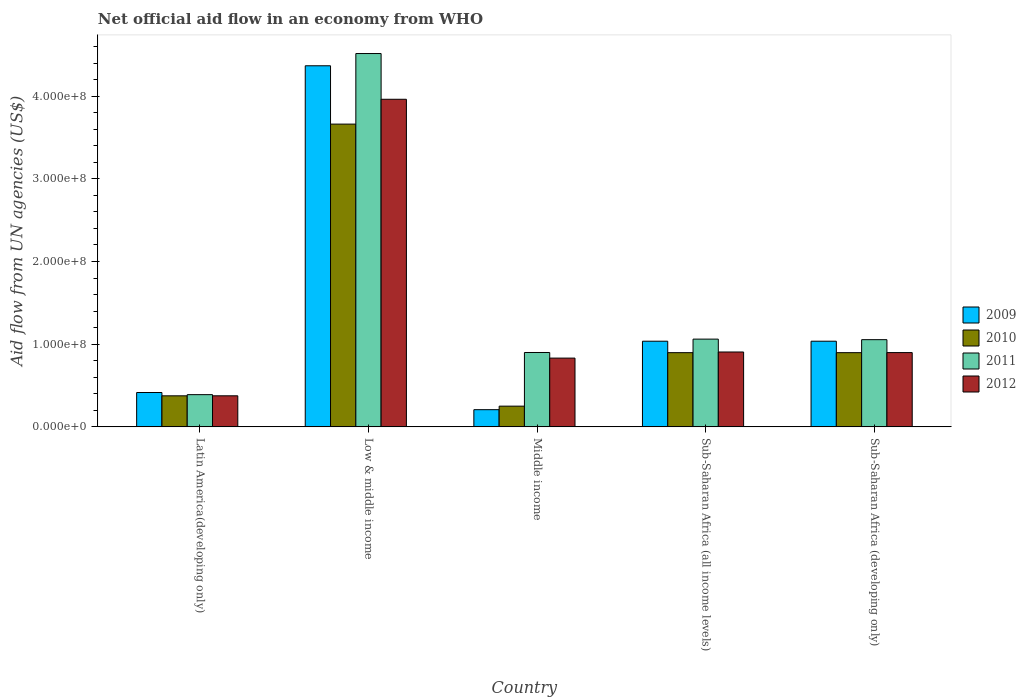How many different coloured bars are there?
Make the answer very short. 4. How many groups of bars are there?
Ensure brevity in your answer.  5. Are the number of bars per tick equal to the number of legend labels?
Your answer should be very brief. Yes. Are the number of bars on each tick of the X-axis equal?
Make the answer very short. Yes. What is the label of the 1st group of bars from the left?
Ensure brevity in your answer.  Latin America(developing only). What is the net official aid flow in 2011 in Latin America(developing only)?
Ensure brevity in your answer.  3.90e+07. Across all countries, what is the maximum net official aid flow in 2010?
Your response must be concise. 3.66e+08. Across all countries, what is the minimum net official aid flow in 2012?
Keep it short and to the point. 3.76e+07. In which country was the net official aid flow in 2011 minimum?
Offer a very short reply. Latin America(developing only). What is the total net official aid flow in 2010 in the graph?
Provide a succinct answer. 6.08e+08. What is the difference between the net official aid flow in 2012 in Middle income and that in Sub-Saharan Africa (all income levels)?
Offer a terse response. -7.39e+06. What is the difference between the net official aid flow in 2010 in Middle income and the net official aid flow in 2011 in Sub-Saharan Africa (all income levels)?
Offer a terse response. -8.11e+07. What is the average net official aid flow in 2009 per country?
Keep it short and to the point. 1.41e+08. What is the difference between the net official aid flow of/in 2011 and net official aid flow of/in 2010 in Low & middle income?
Offer a very short reply. 8.54e+07. In how many countries, is the net official aid flow in 2009 greater than 420000000 US$?
Provide a short and direct response. 1. What is the ratio of the net official aid flow in 2011 in Low & middle income to that in Middle income?
Make the answer very short. 5.02. Is the net official aid flow in 2011 in Latin America(developing only) less than that in Low & middle income?
Give a very brief answer. Yes. Is the difference between the net official aid flow in 2011 in Low & middle income and Sub-Saharan Africa (developing only) greater than the difference between the net official aid flow in 2010 in Low & middle income and Sub-Saharan Africa (developing only)?
Your response must be concise. Yes. What is the difference between the highest and the second highest net official aid flow in 2010?
Your answer should be very brief. 2.76e+08. What is the difference between the highest and the lowest net official aid flow in 2010?
Your answer should be compact. 3.41e+08. In how many countries, is the net official aid flow in 2010 greater than the average net official aid flow in 2010 taken over all countries?
Your response must be concise. 1. Is the sum of the net official aid flow in 2009 in Latin America(developing only) and Sub-Saharan Africa (all income levels) greater than the maximum net official aid flow in 2012 across all countries?
Your response must be concise. No. What does the 4th bar from the right in Sub-Saharan Africa (developing only) represents?
Ensure brevity in your answer.  2009. Is it the case that in every country, the sum of the net official aid flow in 2009 and net official aid flow in 2010 is greater than the net official aid flow in 2011?
Your answer should be very brief. No. Does the graph contain any zero values?
Offer a very short reply. No. How many legend labels are there?
Your answer should be compact. 4. What is the title of the graph?
Provide a succinct answer. Net official aid flow in an economy from WHO. What is the label or title of the X-axis?
Ensure brevity in your answer.  Country. What is the label or title of the Y-axis?
Give a very brief answer. Aid flow from UN agencies (US$). What is the Aid flow from UN agencies (US$) of 2009 in Latin America(developing only)?
Your response must be concise. 4.16e+07. What is the Aid flow from UN agencies (US$) of 2010 in Latin America(developing only)?
Offer a very short reply. 3.76e+07. What is the Aid flow from UN agencies (US$) of 2011 in Latin America(developing only)?
Offer a very short reply. 3.90e+07. What is the Aid flow from UN agencies (US$) in 2012 in Latin America(developing only)?
Your answer should be very brief. 3.76e+07. What is the Aid flow from UN agencies (US$) in 2009 in Low & middle income?
Offer a terse response. 4.37e+08. What is the Aid flow from UN agencies (US$) of 2010 in Low & middle income?
Give a very brief answer. 3.66e+08. What is the Aid flow from UN agencies (US$) in 2011 in Low & middle income?
Your answer should be compact. 4.52e+08. What is the Aid flow from UN agencies (US$) in 2012 in Low & middle income?
Give a very brief answer. 3.96e+08. What is the Aid flow from UN agencies (US$) in 2009 in Middle income?
Offer a terse response. 2.08e+07. What is the Aid flow from UN agencies (US$) in 2010 in Middle income?
Provide a succinct answer. 2.51e+07. What is the Aid flow from UN agencies (US$) in 2011 in Middle income?
Give a very brief answer. 9.00e+07. What is the Aid flow from UN agencies (US$) in 2012 in Middle income?
Provide a short and direct response. 8.32e+07. What is the Aid flow from UN agencies (US$) in 2009 in Sub-Saharan Africa (all income levels)?
Provide a succinct answer. 1.04e+08. What is the Aid flow from UN agencies (US$) of 2010 in Sub-Saharan Africa (all income levels)?
Provide a short and direct response. 8.98e+07. What is the Aid flow from UN agencies (US$) in 2011 in Sub-Saharan Africa (all income levels)?
Make the answer very short. 1.06e+08. What is the Aid flow from UN agencies (US$) of 2012 in Sub-Saharan Africa (all income levels)?
Offer a terse response. 9.06e+07. What is the Aid flow from UN agencies (US$) in 2009 in Sub-Saharan Africa (developing only)?
Make the answer very short. 1.04e+08. What is the Aid flow from UN agencies (US$) in 2010 in Sub-Saharan Africa (developing only)?
Make the answer very short. 8.98e+07. What is the Aid flow from UN agencies (US$) in 2011 in Sub-Saharan Africa (developing only)?
Make the answer very short. 1.05e+08. What is the Aid flow from UN agencies (US$) in 2012 in Sub-Saharan Africa (developing only)?
Provide a succinct answer. 8.98e+07. Across all countries, what is the maximum Aid flow from UN agencies (US$) in 2009?
Your response must be concise. 4.37e+08. Across all countries, what is the maximum Aid flow from UN agencies (US$) in 2010?
Your answer should be compact. 3.66e+08. Across all countries, what is the maximum Aid flow from UN agencies (US$) in 2011?
Your response must be concise. 4.52e+08. Across all countries, what is the maximum Aid flow from UN agencies (US$) of 2012?
Make the answer very short. 3.96e+08. Across all countries, what is the minimum Aid flow from UN agencies (US$) of 2009?
Offer a terse response. 2.08e+07. Across all countries, what is the minimum Aid flow from UN agencies (US$) of 2010?
Give a very brief answer. 2.51e+07. Across all countries, what is the minimum Aid flow from UN agencies (US$) of 2011?
Your response must be concise. 3.90e+07. Across all countries, what is the minimum Aid flow from UN agencies (US$) in 2012?
Make the answer very short. 3.76e+07. What is the total Aid flow from UN agencies (US$) in 2009 in the graph?
Provide a succinct answer. 7.06e+08. What is the total Aid flow from UN agencies (US$) in 2010 in the graph?
Provide a succinct answer. 6.08e+08. What is the total Aid flow from UN agencies (US$) in 2011 in the graph?
Offer a very short reply. 7.92e+08. What is the total Aid flow from UN agencies (US$) of 2012 in the graph?
Make the answer very short. 6.97e+08. What is the difference between the Aid flow from UN agencies (US$) in 2009 in Latin America(developing only) and that in Low & middle income?
Your response must be concise. -3.95e+08. What is the difference between the Aid flow from UN agencies (US$) of 2010 in Latin America(developing only) and that in Low & middle income?
Ensure brevity in your answer.  -3.29e+08. What is the difference between the Aid flow from UN agencies (US$) in 2011 in Latin America(developing only) and that in Low & middle income?
Give a very brief answer. -4.13e+08. What is the difference between the Aid flow from UN agencies (US$) of 2012 in Latin America(developing only) and that in Low & middle income?
Offer a very short reply. -3.59e+08. What is the difference between the Aid flow from UN agencies (US$) of 2009 in Latin America(developing only) and that in Middle income?
Offer a very short reply. 2.08e+07. What is the difference between the Aid flow from UN agencies (US$) in 2010 in Latin America(developing only) and that in Middle income?
Your answer should be very brief. 1.25e+07. What is the difference between the Aid flow from UN agencies (US$) of 2011 in Latin America(developing only) and that in Middle income?
Your answer should be compact. -5.10e+07. What is the difference between the Aid flow from UN agencies (US$) of 2012 in Latin America(developing only) and that in Middle income?
Offer a terse response. -4.56e+07. What is the difference between the Aid flow from UN agencies (US$) of 2009 in Latin America(developing only) and that in Sub-Saharan Africa (all income levels)?
Keep it short and to the point. -6.20e+07. What is the difference between the Aid flow from UN agencies (US$) of 2010 in Latin America(developing only) and that in Sub-Saharan Africa (all income levels)?
Ensure brevity in your answer.  -5.22e+07. What is the difference between the Aid flow from UN agencies (US$) in 2011 in Latin America(developing only) and that in Sub-Saharan Africa (all income levels)?
Make the answer very short. -6.72e+07. What is the difference between the Aid flow from UN agencies (US$) of 2012 in Latin America(developing only) and that in Sub-Saharan Africa (all income levels)?
Provide a short and direct response. -5.30e+07. What is the difference between the Aid flow from UN agencies (US$) in 2009 in Latin America(developing only) and that in Sub-Saharan Africa (developing only)?
Keep it short and to the point. -6.20e+07. What is the difference between the Aid flow from UN agencies (US$) in 2010 in Latin America(developing only) and that in Sub-Saharan Africa (developing only)?
Keep it short and to the point. -5.22e+07. What is the difference between the Aid flow from UN agencies (US$) in 2011 in Latin America(developing only) and that in Sub-Saharan Africa (developing only)?
Your response must be concise. -6.65e+07. What is the difference between the Aid flow from UN agencies (US$) in 2012 in Latin America(developing only) and that in Sub-Saharan Africa (developing only)?
Offer a terse response. -5.23e+07. What is the difference between the Aid flow from UN agencies (US$) in 2009 in Low & middle income and that in Middle income?
Offer a terse response. 4.16e+08. What is the difference between the Aid flow from UN agencies (US$) in 2010 in Low & middle income and that in Middle income?
Ensure brevity in your answer.  3.41e+08. What is the difference between the Aid flow from UN agencies (US$) of 2011 in Low & middle income and that in Middle income?
Make the answer very short. 3.62e+08. What is the difference between the Aid flow from UN agencies (US$) of 2012 in Low & middle income and that in Middle income?
Ensure brevity in your answer.  3.13e+08. What is the difference between the Aid flow from UN agencies (US$) of 2009 in Low & middle income and that in Sub-Saharan Africa (all income levels)?
Offer a very short reply. 3.33e+08. What is the difference between the Aid flow from UN agencies (US$) in 2010 in Low & middle income and that in Sub-Saharan Africa (all income levels)?
Ensure brevity in your answer.  2.76e+08. What is the difference between the Aid flow from UN agencies (US$) of 2011 in Low & middle income and that in Sub-Saharan Africa (all income levels)?
Your answer should be very brief. 3.45e+08. What is the difference between the Aid flow from UN agencies (US$) of 2012 in Low & middle income and that in Sub-Saharan Africa (all income levels)?
Your response must be concise. 3.06e+08. What is the difference between the Aid flow from UN agencies (US$) in 2009 in Low & middle income and that in Sub-Saharan Africa (developing only)?
Offer a terse response. 3.33e+08. What is the difference between the Aid flow from UN agencies (US$) in 2010 in Low & middle income and that in Sub-Saharan Africa (developing only)?
Provide a short and direct response. 2.76e+08. What is the difference between the Aid flow from UN agencies (US$) in 2011 in Low & middle income and that in Sub-Saharan Africa (developing only)?
Offer a terse response. 3.46e+08. What is the difference between the Aid flow from UN agencies (US$) in 2012 in Low & middle income and that in Sub-Saharan Africa (developing only)?
Ensure brevity in your answer.  3.06e+08. What is the difference between the Aid flow from UN agencies (US$) of 2009 in Middle income and that in Sub-Saharan Africa (all income levels)?
Keep it short and to the point. -8.28e+07. What is the difference between the Aid flow from UN agencies (US$) in 2010 in Middle income and that in Sub-Saharan Africa (all income levels)?
Offer a terse response. -6.47e+07. What is the difference between the Aid flow from UN agencies (US$) in 2011 in Middle income and that in Sub-Saharan Africa (all income levels)?
Your response must be concise. -1.62e+07. What is the difference between the Aid flow from UN agencies (US$) in 2012 in Middle income and that in Sub-Saharan Africa (all income levels)?
Offer a very short reply. -7.39e+06. What is the difference between the Aid flow from UN agencies (US$) of 2009 in Middle income and that in Sub-Saharan Africa (developing only)?
Ensure brevity in your answer.  -8.28e+07. What is the difference between the Aid flow from UN agencies (US$) in 2010 in Middle income and that in Sub-Saharan Africa (developing only)?
Keep it short and to the point. -6.47e+07. What is the difference between the Aid flow from UN agencies (US$) of 2011 in Middle income and that in Sub-Saharan Africa (developing only)?
Your response must be concise. -1.55e+07. What is the difference between the Aid flow from UN agencies (US$) in 2012 in Middle income and that in Sub-Saharan Africa (developing only)?
Provide a short and direct response. -6.67e+06. What is the difference between the Aid flow from UN agencies (US$) of 2009 in Sub-Saharan Africa (all income levels) and that in Sub-Saharan Africa (developing only)?
Make the answer very short. 0. What is the difference between the Aid flow from UN agencies (US$) in 2011 in Sub-Saharan Africa (all income levels) and that in Sub-Saharan Africa (developing only)?
Your answer should be compact. 6.70e+05. What is the difference between the Aid flow from UN agencies (US$) in 2012 in Sub-Saharan Africa (all income levels) and that in Sub-Saharan Africa (developing only)?
Provide a short and direct response. 7.20e+05. What is the difference between the Aid flow from UN agencies (US$) in 2009 in Latin America(developing only) and the Aid flow from UN agencies (US$) in 2010 in Low & middle income?
Ensure brevity in your answer.  -3.25e+08. What is the difference between the Aid flow from UN agencies (US$) in 2009 in Latin America(developing only) and the Aid flow from UN agencies (US$) in 2011 in Low & middle income?
Give a very brief answer. -4.10e+08. What is the difference between the Aid flow from UN agencies (US$) in 2009 in Latin America(developing only) and the Aid flow from UN agencies (US$) in 2012 in Low & middle income?
Give a very brief answer. -3.55e+08. What is the difference between the Aid flow from UN agencies (US$) in 2010 in Latin America(developing only) and the Aid flow from UN agencies (US$) in 2011 in Low & middle income?
Your response must be concise. -4.14e+08. What is the difference between the Aid flow from UN agencies (US$) of 2010 in Latin America(developing only) and the Aid flow from UN agencies (US$) of 2012 in Low & middle income?
Your response must be concise. -3.59e+08. What is the difference between the Aid flow from UN agencies (US$) in 2011 in Latin America(developing only) and the Aid flow from UN agencies (US$) in 2012 in Low & middle income?
Keep it short and to the point. -3.57e+08. What is the difference between the Aid flow from UN agencies (US$) of 2009 in Latin America(developing only) and the Aid flow from UN agencies (US$) of 2010 in Middle income?
Give a very brief answer. 1.65e+07. What is the difference between the Aid flow from UN agencies (US$) in 2009 in Latin America(developing only) and the Aid flow from UN agencies (US$) in 2011 in Middle income?
Your answer should be very brief. -4.84e+07. What is the difference between the Aid flow from UN agencies (US$) of 2009 in Latin America(developing only) and the Aid flow from UN agencies (US$) of 2012 in Middle income?
Keep it short and to the point. -4.16e+07. What is the difference between the Aid flow from UN agencies (US$) of 2010 in Latin America(developing only) and the Aid flow from UN agencies (US$) of 2011 in Middle income?
Keep it short and to the point. -5.24e+07. What is the difference between the Aid flow from UN agencies (US$) in 2010 in Latin America(developing only) and the Aid flow from UN agencies (US$) in 2012 in Middle income?
Your answer should be compact. -4.56e+07. What is the difference between the Aid flow from UN agencies (US$) of 2011 in Latin America(developing only) and the Aid flow from UN agencies (US$) of 2012 in Middle income?
Offer a very short reply. -4.42e+07. What is the difference between the Aid flow from UN agencies (US$) in 2009 in Latin America(developing only) and the Aid flow from UN agencies (US$) in 2010 in Sub-Saharan Africa (all income levels)?
Provide a short and direct response. -4.82e+07. What is the difference between the Aid flow from UN agencies (US$) in 2009 in Latin America(developing only) and the Aid flow from UN agencies (US$) in 2011 in Sub-Saharan Africa (all income levels)?
Give a very brief answer. -6.46e+07. What is the difference between the Aid flow from UN agencies (US$) of 2009 in Latin America(developing only) and the Aid flow from UN agencies (US$) of 2012 in Sub-Saharan Africa (all income levels)?
Provide a short and direct response. -4.90e+07. What is the difference between the Aid flow from UN agencies (US$) in 2010 in Latin America(developing only) and the Aid flow from UN agencies (US$) in 2011 in Sub-Saharan Africa (all income levels)?
Ensure brevity in your answer.  -6.86e+07. What is the difference between the Aid flow from UN agencies (US$) in 2010 in Latin America(developing only) and the Aid flow from UN agencies (US$) in 2012 in Sub-Saharan Africa (all income levels)?
Provide a succinct answer. -5.30e+07. What is the difference between the Aid flow from UN agencies (US$) of 2011 in Latin America(developing only) and the Aid flow from UN agencies (US$) of 2012 in Sub-Saharan Africa (all income levels)?
Your answer should be compact. -5.16e+07. What is the difference between the Aid flow from UN agencies (US$) in 2009 in Latin America(developing only) and the Aid flow from UN agencies (US$) in 2010 in Sub-Saharan Africa (developing only)?
Keep it short and to the point. -4.82e+07. What is the difference between the Aid flow from UN agencies (US$) of 2009 in Latin America(developing only) and the Aid flow from UN agencies (US$) of 2011 in Sub-Saharan Africa (developing only)?
Keep it short and to the point. -6.39e+07. What is the difference between the Aid flow from UN agencies (US$) of 2009 in Latin America(developing only) and the Aid flow from UN agencies (US$) of 2012 in Sub-Saharan Africa (developing only)?
Provide a succinct answer. -4.83e+07. What is the difference between the Aid flow from UN agencies (US$) of 2010 in Latin America(developing only) and the Aid flow from UN agencies (US$) of 2011 in Sub-Saharan Africa (developing only)?
Make the answer very short. -6.79e+07. What is the difference between the Aid flow from UN agencies (US$) of 2010 in Latin America(developing only) and the Aid flow from UN agencies (US$) of 2012 in Sub-Saharan Africa (developing only)?
Provide a short and direct response. -5.23e+07. What is the difference between the Aid flow from UN agencies (US$) in 2011 in Latin America(developing only) and the Aid flow from UN agencies (US$) in 2012 in Sub-Saharan Africa (developing only)?
Give a very brief answer. -5.09e+07. What is the difference between the Aid flow from UN agencies (US$) of 2009 in Low & middle income and the Aid flow from UN agencies (US$) of 2010 in Middle income?
Your answer should be very brief. 4.12e+08. What is the difference between the Aid flow from UN agencies (US$) in 2009 in Low & middle income and the Aid flow from UN agencies (US$) in 2011 in Middle income?
Your answer should be very brief. 3.47e+08. What is the difference between the Aid flow from UN agencies (US$) in 2009 in Low & middle income and the Aid flow from UN agencies (US$) in 2012 in Middle income?
Ensure brevity in your answer.  3.54e+08. What is the difference between the Aid flow from UN agencies (US$) of 2010 in Low & middle income and the Aid flow from UN agencies (US$) of 2011 in Middle income?
Provide a succinct answer. 2.76e+08. What is the difference between the Aid flow from UN agencies (US$) of 2010 in Low & middle income and the Aid flow from UN agencies (US$) of 2012 in Middle income?
Your answer should be compact. 2.83e+08. What is the difference between the Aid flow from UN agencies (US$) of 2011 in Low & middle income and the Aid flow from UN agencies (US$) of 2012 in Middle income?
Your response must be concise. 3.68e+08. What is the difference between the Aid flow from UN agencies (US$) in 2009 in Low & middle income and the Aid flow from UN agencies (US$) in 2010 in Sub-Saharan Africa (all income levels)?
Keep it short and to the point. 3.47e+08. What is the difference between the Aid flow from UN agencies (US$) of 2009 in Low & middle income and the Aid flow from UN agencies (US$) of 2011 in Sub-Saharan Africa (all income levels)?
Your response must be concise. 3.31e+08. What is the difference between the Aid flow from UN agencies (US$) of 2009 in Low & middle income and the Aid flow from UN agencies (US$) of 2012 in Sub-Saharan Africa (all income levels)?
Ensure brevity in your answer.  3.46e+08. What is the difference between the Aid flow from UN agencies (US$) in 2010 in Low & middle income and the Aid flow from UN agencies (US$) in 2011 in Sub-Saharan Africa (all income levels)?
Offer a terse response. 2.60e+08. What is the difference between the Aid flow from UN agencies (US$) of 2010 in Low & middle income and the Aid flow from UN agencies (US$) of 2012 in Sub-Saharan Africa (all income levels)?
Your answer should be compact. 2.76e+08. What is the difference between the Aid flow from UN agencies (US$) of 2011 in Low & middle income and the Aid flow from UN agencies (US$) of 2012 in Sub-Saharan Africa (all income levels)?
Your answer should be very brief. 3.61e+08. What is the difference between the Aid flow from UN agencies (US$) of 2009 in Low & middle income and the Aid flow from UN agencies (US$) of 2010 in Sub-Saharan Africa (developing only)?
Keep it short and to the point. 3.47e+08. What is the difference between the Aid flow from UN agencies (US$) in 2009 in Low & middle income and the Aid flow from UN agencies (US$) in 2011 in Sub-Saharan Africa (developing only)?
Make the answer very short. 3.31e+08. What is the difference between the Aid flow from UN agencies (US$) in 2009 in Low & middle income and the Aid flow from UN agencies (US$) in 2012 in Sub-Saharan Africa (developing only)?
Offer a very short reply. 3.47e+08. What is the difference between the Aid flow from UN agencies (US$) in 2010 in Low & middle income and the Aid flow from UN agencies (US$) in 2011 in Sub-Saharan Africa (developing only)?
Your answer should be very brief. 2.61e+08. What is the difference between the Aid flow from UN agencies (US$) of 2010 in Low & middle income and the Aid flow from UN agencies (US$) of 2012 in Sub-Saharan Africa (developing only)?
Offer a very short reply. 2.76e+08. What is the difference between the Aid flow from UN agencies (US$) in 2011 in Low & middle income and the Aid flow from UN agencies (US$) in 2012 in Sub-Saharan Africa (developing only)?
Offer a terse response. 3.62e+08. What is the difference between the Aid flow from UN agencies (US$) of 2009 in Middle income and the Aid flow from UN agencies (US$) of 2010 in Sub-Saharan Africa (all income levels)?
Your answer should be compact. -6.90e+07. What is the difference between the Aid flow from UN agencies (US$) of 2009 in Middle income and the Aid flow from UN agencies (US$) of 2011 in Sub-Saharan Africa (all income levels)?
Ensure brevity in your answer.  -8.54e+07. What is the difference between the Aid flow from UN agencies (US$) in 2009 in Middle income and the Aid flow from UN agencies (US$) in 2012 in Sub-Saharan Africa (all income levels)?
Provide a succinct answer. -6.98e+07. What is the difference between the Aid flow from UN agencies (US$) in 2010 in Middle income and the Aid flow from UN agencies (US$) in 2011 in Sub-Saharan Africa (all income levels)?
Offer a very short reply. -8.11e+07. What is the difference between the Aid flow from UN agencies (US$) of 2010 in Middle income and the Aid flow from UN agencies (US$) of 2012 in Sub-Saharan Africa (all income levels)?
Offer a very short reply. -6.55e+07. What is the difference between the Aid flow from UN agencies (US$) in 2011 in Middle income and the Aid flow from UN agencies (US$) in 2012 in Sub-Saharan Africa (all income levels)?
Keep it short and to the point. -5.90e+05. What is the difference between the Aid flow from UN agencies (US$) in 2009 in Middle income and the Aid flow from UN agencies (US$) in 2010 in Sub-Saharan Africa (developing only)?
Give a very brief answer. -6.90e+07. What is the difference between the Aid flow from UN agencies (US$) in 2009 in Middle income and the Aid flow from UN agencies (US$) in 2011 in Sub-Saharan Africa (developing only)?
Your answer should be very brief. -8.47e+07. What is the difference between the Aid flow from UN agencies (US$) of 2009 in Middle income and the Aid flow from UN agencies (US$) of 2012 in Sub-Saharan Africa (developing only)?
Your answer should be very brief. -6.90e+07. What is the difference between the Aid flow from UN agencies (US$) in 2010 in Middle income and the Aid flow from UN agencies (US$) in 2011 in Sub-Saharan Africa (developing only)?
Provide a short and direct response. -8.04e+07. What is the difference between the Aid flow from UN agencies (US$) in 2010 in Middle income and the Aid flow from UN agencies (US$) in 2012 in Sub-Saharan Africa (developing only)?
Make the answer very short. -6.48e+07. What is the difference between the Aid flow from UN agencies (US$) of 2011 in Middle income and the Aid flow from UN agencies (US$) of 2012 in Sub-Saharan Africa (developing only)?
Keep it short and to the point. 1.30e+05. What is the difference between the Aid flow from UN agencies (US$) of 2009 in Sub-Saharan Africa (all income levels) and the Aid flow from UN agencies (US$) of 2010 in Sub-Saharan Africa (developing only)?
Your answer should be very brief. 1.39e+07. What is the difference between the Aid flow from UN agencies (US$) in 2009 in Sub-Saharan Africa (all income levels) and the Aid flow from UN agencies (US$) in 2011 in Sub-Saharan Africa (developing only)?
Offer a very short reply. -1.86e+06. What is the difference between the Aid flow from UN agencies (US$) of 2009 in Sub-Saharan Africa (all income levels) and the Aid flow from UN agencies (US$) of 2012 in Sub-Saharan Africa (developing only)?
Your answer should be very brief. 1.38e+07. What is the difference between the Aid flow from UN agencies (US$) of 2010 in Sub-Saharan Africa (all income levels) and the Aid flow from UN agencies (US$) of 2011 in Sub-Saharan Africa (developing only)?
Ensure brevity in your answer.  -1.57e+07. What is the difference between the Aid flow from UN agencies (US$) of 2010 in Sub-Saharan Africa (all income levels) and the Aid flow from UN agencies (US$) of 2012 in Sub-Saharan Africa (developing only)?
Your answer should be compact. -9.00e+04. What is the difference between the Aid flow from UN agencies (US$) in 2011 in Sub-Saharan Africa (all income levels) and the Aid flow from UN agencies (US$) in 2012 in Sub-Saharan Africa (developing only)?
Give a very brief answer. 1.63e+07. What is the average Aid flow from UN agencies (US$) in 2009 per country?
Your answer should be compact. 1.41e+08. What is the average Aid flow from UN agencies (US$) of 2010 per country?
Give a very brief answer. 1.22e+08. What is the average Aid flow from UN agencies (US$) of 2011 per country?
Make the answer very short. 1.58e+08. What is the average Aid flow from UN agencies (US$) in 2012 per country?
Keep it short and to the point. 1.39e+08. What is the difference between the Aid flow from UN agencies (US$) of 2009 and Aid flow from UN agencies (US$) of 2010 in Latin America(developing only)?
Offer a very short reply. 4.01e+06. What is the difference between the Aid flow from UN agencies (US$) of 2009 and Aid flow from UN agencies (US$) of 2011 in Latin America(developing only)?
Offer a terse response. 2.59e+06. What is the difference between the Aid flow from UN agencies (US$) in 2009 and Aid flow from UN agencies (US$) in 2012 in Latin America(developing only)?
Keep it short and to the point. 3.99e+06. What is the difference between the Aid flow from UN agencies (US$) of 2010 and Aid flow from UN agencies (US$) of 2011 in Latin America(developing only)?
Ensure brevity in your answer.  -1.42e+06. What is the difference between the Aid flow from UN agencies (US$) of 2011 and Aid flow from UN agencies (US$) of 2012 in Latin America(developing only)?
Your response must be concise. 1.40e+06. What is the difference between the Aid flow from UN agencies (US$) in 2009 and Aid flow from UN agencies (US$) in 2010 in Low & middle income?
Provide a short and direct response. 7.06e+07. What is the difference between the Aid flow from UN agencies (US$) of 2009 and Aid flow from UN agencies (US$) of 2011 in Low & middle income?
Give a very brief answer. -1.48e+07. What is the difference between the Aid flow from UN agencies (US$) in 2009 and Aid flow from UN agencies (US$) in 2012 in Low & middle income?
Your response must be concise. 4.05e+07. What is the difference between the Aid flow from UN agencies (US$) in 2010 and Aid flow from UN agencies (US$) in 2011 in Low & middle income?
Ensure brevity in your answer.  -8.54e+07. What is the difference between the Aid flow from UN agencies (US$) in 2010 and Aid flow from UN agencies (US$) in 2012 in Low & middle income?
Offer a very short reply. -3.00e+07. What is the difference between the Aid flow from UN agencies (US$) of 2011 and Aid flow from UN agencies (US$) of 2012 in Low & middle income?
Make the answer very short. 5.53e+07. What is the difference between the Aid flow from UN agencies (US$) of 2009 and Aid flow from UN agencies (US$) of 2010 in Middle income?
Provide a succinct answer. -4.27e+06. What is the difference between the Aid flow from UN agencies (US$) in 2009 and Aid flow from UN agencies (US$) in 2011 in Middle income?
Make the answer very short. -6.92e+07. What is the difference between the Aid flow from UN agencies (US$) of 2009 and Aid flow from UN agencies (US$) of 2012 in Middle income?
Provide a succinct answer. -6.24e+07. What is the difference between the Aid flow from UN agencies (US$) in 2010 and Aid flow from UN agencies (US$) in 2011 in Middle income?
Keep it short and to the point. -6.49e+07. What is the difference between the Aid flow from UN agencies (US$) of 2010 and Aid flow from UN agencies (US$) of 2012 in Middle income?
Offer a terse response. -5.81e+07. What is the difference between the Aid flow from UN agencies (US$) in 2011 and Aid flow from UN agencies (US$) in 2012 in Middle income?
Give a very brief answer. 6.80e+06. What is the difference between the Aid flow from UN agencies (US$) in 2009 and Aid flow from UN agencies (US$) in 2010 in Sub-Saharan Africa (all income levels)?
Make the answer very short. 1.39e+07. What is the difference between the Aid flow from UN agencies (US$) in 2009 and Aid flow from UN agencies (US$) in 2011 in Sub-Saharan Africa (all income levels)?
Your response must be concise. -2.53e+06. What is the difference between the Aid flow from UN agencies (US$) in 2009 and Aid flow from UN agencies (US$) in 2012 in Sub-Saharan Africa (all income levels)?
Provide a short and direct response. 1.30e+07. What is the difference between the Aid flow from UN agencies (US$) in 2010 and Aid flow from UN agencies (US$) in 2011 in Sub-Saharan Africa (all income levels)?
Offer a very short reply. -1.64e+07. What is the difference between the Aid flow from UN agencies (US$) of 2010 and Aid flow from UN agencies (US$) of 2012 in Sub-Saharan Africa (all income levels)?
Provide a short and direct response. -8.10e+05. What is the difference between the Aid flow from UN agencies (US$) in 2011 and Aid flow from UN agencies (US$) in 2012 in Sub-Saharan Africa (all income levels)?
Provide a short and direct response. 1.56e+07. What is the difference between the Aid flow from UN agencies (US$) in 2009 and Aid flow from UN agencies (US$) in 2010 in Sub-Saharan Africa (developing only)?
Offer a very short reply. 1.39e+07. What is the difference between the Aid flow from UN agencies (US$) in 2009 and Aid flow from UN agencies (US$) in 2011 in Sub-Saharan Africa (developing only)?
Your response must be concise. -1.86e+06. What is the difference between the Aid flow from UN agencies (US$) of 2009 and Aid flow from UN agencies (US$) of 2012 in Sub-Saharan Africa (developing only)?
Your answer should be compact. 1.38e+07. What is the difference between the Aid flow from UN agencies (US$) in 2010 and Aid flow from UN agencies (US$) in 2011 in Sub-Saharan Africa (developing only)?
Offer a very short reply. -1.57e+07. What is the difference between the Aid flow from UN agencies (US$) in 2011 and Aid flow from UN agencies (US$) in 2012 in Sub-Saharan Africa (developing only)?
Your answer should be very brief. 1.56e+07. What is the ratio of the Aid flow from UN agencies (US$) in 2009 in Latin America(developing only) to that in Low & middle income?
Ensure brevity in your answer.  0.1. What is the ratio of the Aid flow from UN agencies (US$) in 2010 in Latin America(developing only) to that in Low & middle income?
Your answer should be compact. 0.1. What is the ratio of the Aid flow from UN agencies (US$) in 2011 in Latin America(developing only) to that in Low & middle income?
Your answer should be compact. 0.09. What is the ratio of the Aid flow from UN agencies (US$) in 2012 in Latin America(developing only) to that in Low & middle income?
Offer a terse response. 0.09. What is the ratio of the Aid flow from UN agencies (US$) in 2009 in Latin America(developing only) to that in Middle income?
Give a very brief answer. 2. What is the ratio of the Aid flow from UN agencies (US$) in 2010 in Latin America(developing only) to that in Middle income?
Provide a short and direct response. 1.5. What is the ratio of the Aid flow from UN agencies (US$) in 2011 in Latin America(developing only) to that in Middle income?
Your response must be concise. 0.43. What is the ratio of the Aid flow from UN agencies (US$) of 2012 in Latin America(developing only) to that in Middle income?
Give a very brief answer. 0.45. What is the ratio of the Aid flow from UN agencies (US$) of 2009 in Latin America(developing only) to that in Sub-Saharan Africa (all income levels)?
Provide a short and direct response. 0.4. What is the ratio of the Aid flow from UN agencies (US$) of 2010 in Latin America(developing only) to that in Sub-Saharan Africa (all income levels)?
Your answer should be very brief. 0.42. What is the ratio of the Aid flow from UN agencies (US$) in 2011 in Latin America(developing only) to that in Sub-Saharan Africa (all income levels)?
Offer a very short reply. 0.37. What is the ratio of the Aid flow from UN agencies (US$) in 2012 in Latin America(developing only) to that in Sub-Saharan Africa (all income levels)?
Your answer should be compact. 0.41. What is the ratio of the Aid flow from UN agencies (US$) of 2009 in Latin America(developing only) to that in Sub-Saharan Africa (developing only)?
Keep it short and to the point. 0.4. What is the ratio of the Aid flow from UN agencies (US$) of 2010 in Latin America(developing only) to that in Sub-Saharan Africa (developing only)?
Keep it short and to the point. 0.42. What is the ratio of the Aid flow from UN agencies (US$) in 2011 in Latin America(developing only) to that in Sub-Saharan Africa (developing only)?
Your answer should be compact. 0.37. What is the ratio of the Aid flow from UN agencies (US$) in 2012 in Latin America(developing only) to that in Sub-Saharan Africa (developing only)?
Give a very brief answer. 0.42. What is the ratio of the Aid flow from UN agencies (US$) of 2009 in Low & middle income to that in Middle income?
Your response must be concise. 21. What is the ratio of the Aid flow from UN agencies (US$) in 2010 in Low & middle income to that in Middle income?
Your response must be concise. 14.61. What is the ratio of the Aid flow from UN agencies (US$) of 2011 in Low & middle income to that in Middle income?
Offer a terse response. 5.02. What is the ratio of the Aid flow from UN agencies (US$) of 2012 in Low & middle income to that in Middle income?
Provide a short and direct response. 4.76. What is the ratio of the Aid flow from UN agencies (US$) in 2009 in Low & middle income to that in Sub-Saharan Africa (all income levels)?
Your answer should be very brief. 4.22. What is the ratio of the Aid flow from UN agencies (US$) in 2010 in Low & middle income to that in Sub-Saharan Africa (all income levels)?
Offer a very short reply. 4.08. What is the ratio of the Aid flow from UN agencies (US$) of 2011 in Low & middle income to that in Sub-Saharan Africa (all income levels)?
Keep it short and to the point. 4.25. What is the ratio of the Aid flow from UN agencies (US$) of 2012 in Low & middle income to that in Sub-Saharan Africa (all income levels)?
Give a very brief answer. 4.38. What is the ratio of the Aid flow from UN agencies (US$) in 2009 in Low & middle income to that in Sub-Saharan Africa (developing only)?
Provide a succinct answer. 4.22. What is the ratio of the Aid flow from UN agencies (US$) of 2010 in Low & middle income to that in Sub-Saharan Africa (developing only)?
Your response must be concise. 4.08. What is the ratio of the Aid flow from UN agencies (US$) in 2011 in Low & middle income to that in Sub-Saharan Africa (developing only)?
Ensure brevity in your answer.  4.28. What is the ratio of the Aid flow from UN agencies (US$) in 2012 in Low & middle income to that in Sub-Saharan Africa (developing only)?
Keep it short and to the point. 4.41. What is the ratio of the Aid flow from UN agencies (US$) in 2009 in Middle income to that in Sub-Saharan Africa (all income levels)?
Give a very brief answer. 0.2. What is the ratio of the Aid flow from UN agencies (US$) in 2010 in Middle income to that in Sub-Saharan Africa (all income levels)?
Offer a very short reply. 0.28. What is the ratio of the Aid flow from UN agencies (US$) of 2011 in Middle income to that in Sub-Saharan Africa (all income levels)?
Offer a very short reply. 0.85. What is the ratio of the Aid flow from UN agencies (US$) of 2012 in Middle income to that in Sub-Saharan Africa (all income levels)?
Your answer should be compact. 0.92. What is the ratio of the Aid flow from UN agencies (US$) in 2009 in Middle income to that in Sub-Saharan Africa (developing only)?
Your response must be concise. 0.2. What is the ratio of the Aid flow from UN agencies (US$) in 2010 in Middle income to that in Sub-Saharan Africa (developing only)?
Keep it short and to the point. 0.28. What is the ratio of the Aid flow from UN agencies (US$) in 2011 in Middle income to that in Sub-Saharan Africa (developing only)?
Ensure brevity in your answer.  0.85. What is the ratio of the Aid flow from UN agencies (US$) of 2012 in Middle income to that in Sub-Saharan Africa (developing only)?
Ensure brevity in your answer.  0.93. What is the ratio of the Aid flow from UN agencies (US$) in 2009 in Sub-Saharan Africa (all income levels) to that in Sub-Saharan Africa (developing only)?
Ensure brevity in your answer.  1. What is the ratio of the Aid flow from UN agencies (US$) in 2011 in Sub-Saharan Africa (all income levels) to that in Sub-Saharan Africa (developing only)?
Keep it short and to the point. 1.01. What is the ratio of the Aid flow from UN agencies (US$) in 2012 in Sub-Saharan Africa (all income levels) to that in Sub-Saharan Africa (developing only)?
Offer a terse response. 1.01. What is the difference between the highest and the second highest Aid flow from UN agencies (US$) in 2009?
Give a very brief answer. 3.33e+08. What is the difference between the highest and the second highest Aid flow from UN agencies (US$) in 2010?
Offer a very short reply. 2.76e+08. What is the difference between the highest and the second highest Aid flow from UN agencies (US$) of 2011?
Your answer should be compact. 3.45e+08. What is the difference between the highest and the second highest Aid flow from UN agencies (US$) in 2012?
Make the answer very short. 3.06e+08. What is the difference between the highest and the lowest Aid flow from UN agencies (US$) of 2009?
Make the answer very short. 4.16e+08. What is the difference between the highest and the lowest Aid flow from UN agencies (US$) of 2010?
Offer a very short reply. 3.41e+08. What is the difference between the highest and the lowest Aid flow from UN agencies (US$) of 2011?
Ensure brevity in your answer.  4.13e+08. What is the difference between the highest and the lowest Aid flow from UN agencies (US$) in 2012?
Offer a terse response. 3.59e+08. 